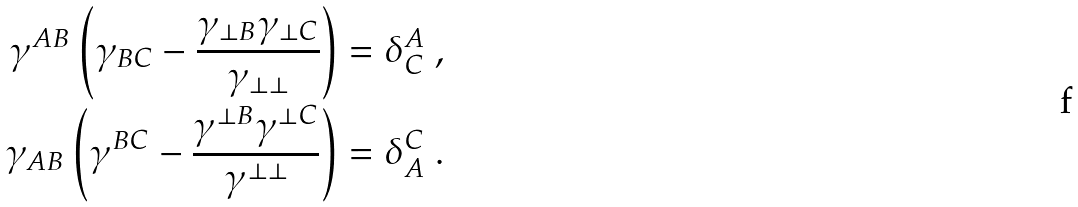<formula> <loc_0><loc_0><loc_500><loc_500>\gamma ^ { A B } \left ( \gamma _ { B C } - \frac { \gamma _ { \perp B } \gamma _ { \perp C } } { \gamma _ { \perp \perp } } \right ) & = \delta ^ { A } _ { C } \ , \\ \gamma _ { A B } \left ( \gamma ^ { B C } - \frac { \gamma ^ { \perp B } \gamma ^ { \perp C } } { \gamma ^ { \perp \perp } } \right ) & = \delta _ { A } ^ { C } \ .</formula> 